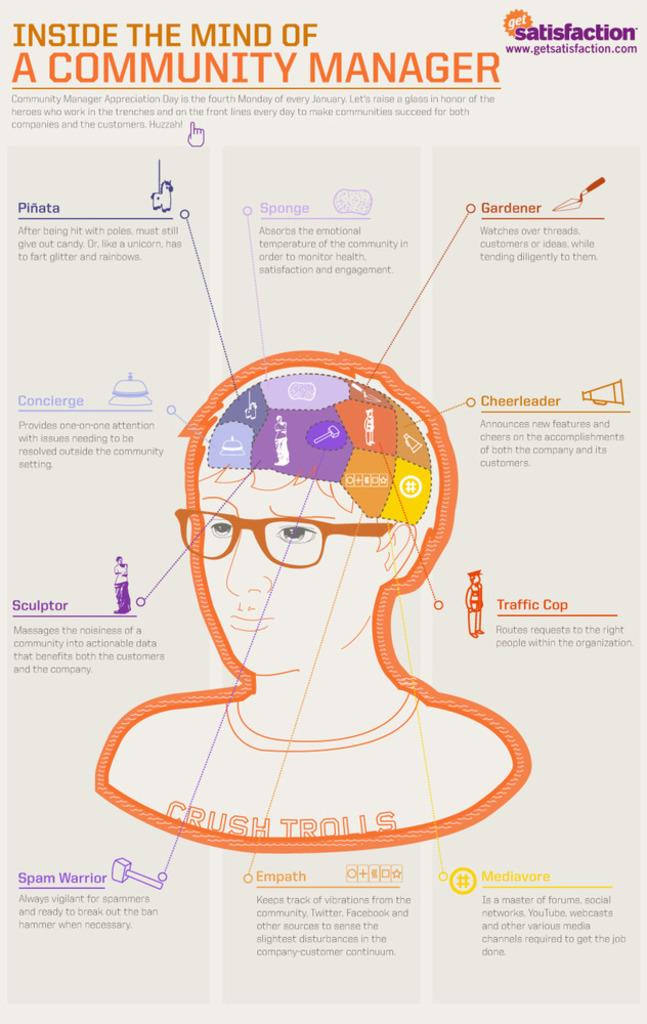What is the title of the poster in the image? The poster is titled "INSIDE THE MIND OF A COMMUNITY MANAGER." What does the poster represent? The poster represents human brains and daily activities. What type of volcano can be seen erupting in the image? There is no volcano present in the image; the poster represents human brains and daily activities. What color is the ink used to write the title of the poster? The provided facts do not mention the color of the ink used to write the title of the poster. 